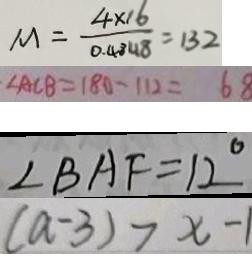<formula> <loc_0><loc_0><loc_500><loc_500>M = \frac { 4 \times 1 6 } { 0 . 4 8 4 8 } = 1 3 2 
 \angle A C B = 1 8 0 - 1 1 2 = 6 8 
 \angle B A F = 1 2 ^ { \circ } 
 ( a - 3 ) > x - 1</formula> 